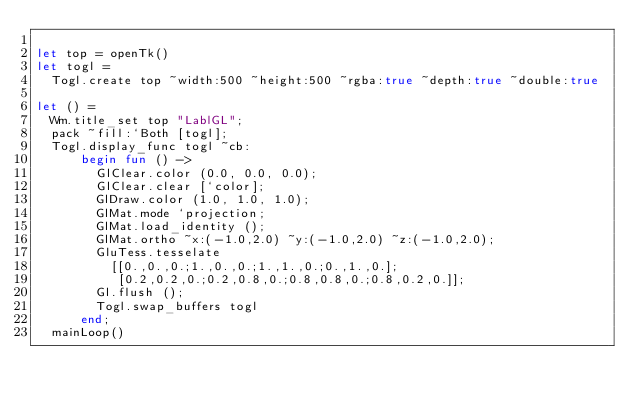<code> <loc_0><loc_0><loc_500><loc_500><_OCaml_>
let top = openTk()
let togl =
  Togl.create top ~width:500 ~height:500 ~rgba:true ~depth:true ~double:true

let () =
  Wm.title_set top "LablGL";
  pack ~fill:`Both [togl];
  Togl.display_func togl ~cb:
      begin fun () ->
        GlClear.color (0.0, 0.0, 0.0);
        GlClear.clear [`color];
        GlDraw.color (1.0, 1.0, 1.0);
        GlMat.mode `projection;
        GlMat.load_identity ();
        GlMat.ortho ~x:(-1.0,2.0) ~y:(-1.0,2.0) ~z:(-1.0,2.0);
        GluTess.tesselate
          [[0.,0.,0.;1.,0.,0.;1.,1.,0.;0.,1.,0.];
           [0.2,0.2,0.;0.2,0.8,0.;0.8,0.8,0.;0.8,0.2,0.]];
        Gl.flush ();
        Togl.swap_buffers togl
      end;
  mainLoop()
</code> 